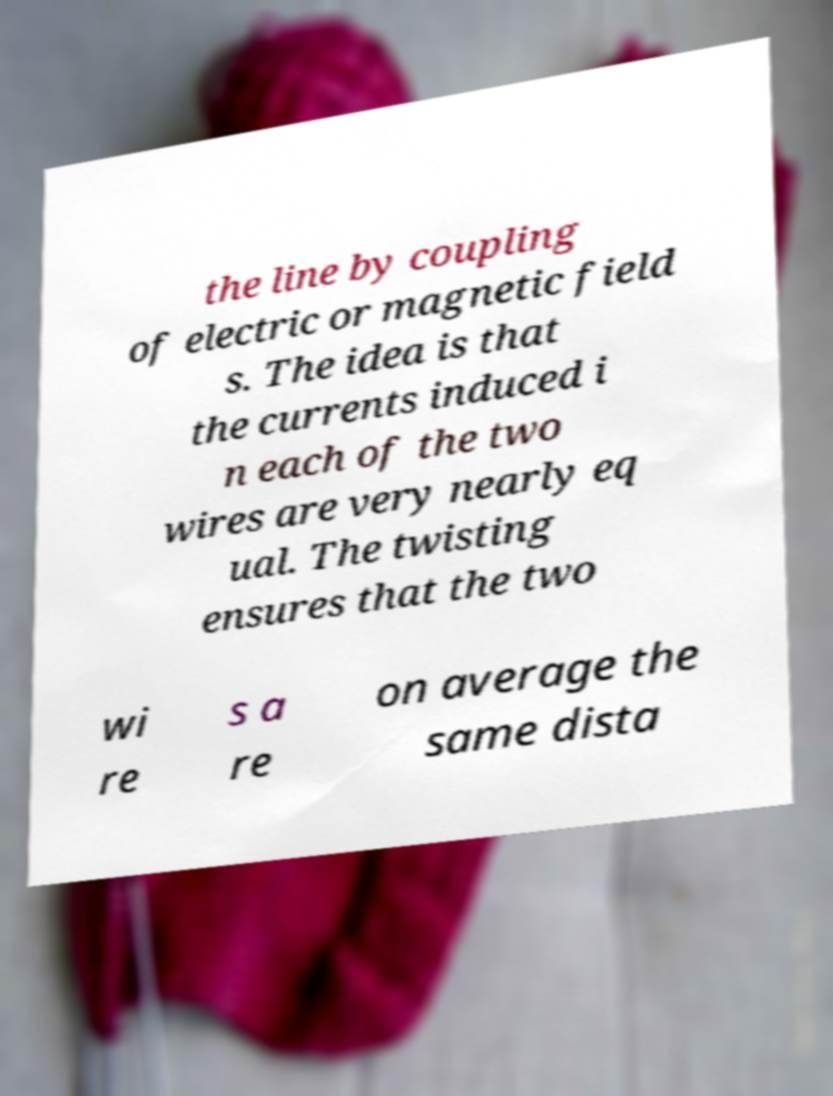Could you extract and type out the text from this image? the line by coupling of electric or magnetic field s. The idea is that the currents induced i n each of the two wires are very nearly eq ual. The twisting ensures that the two wi re s a re on average the same dista 